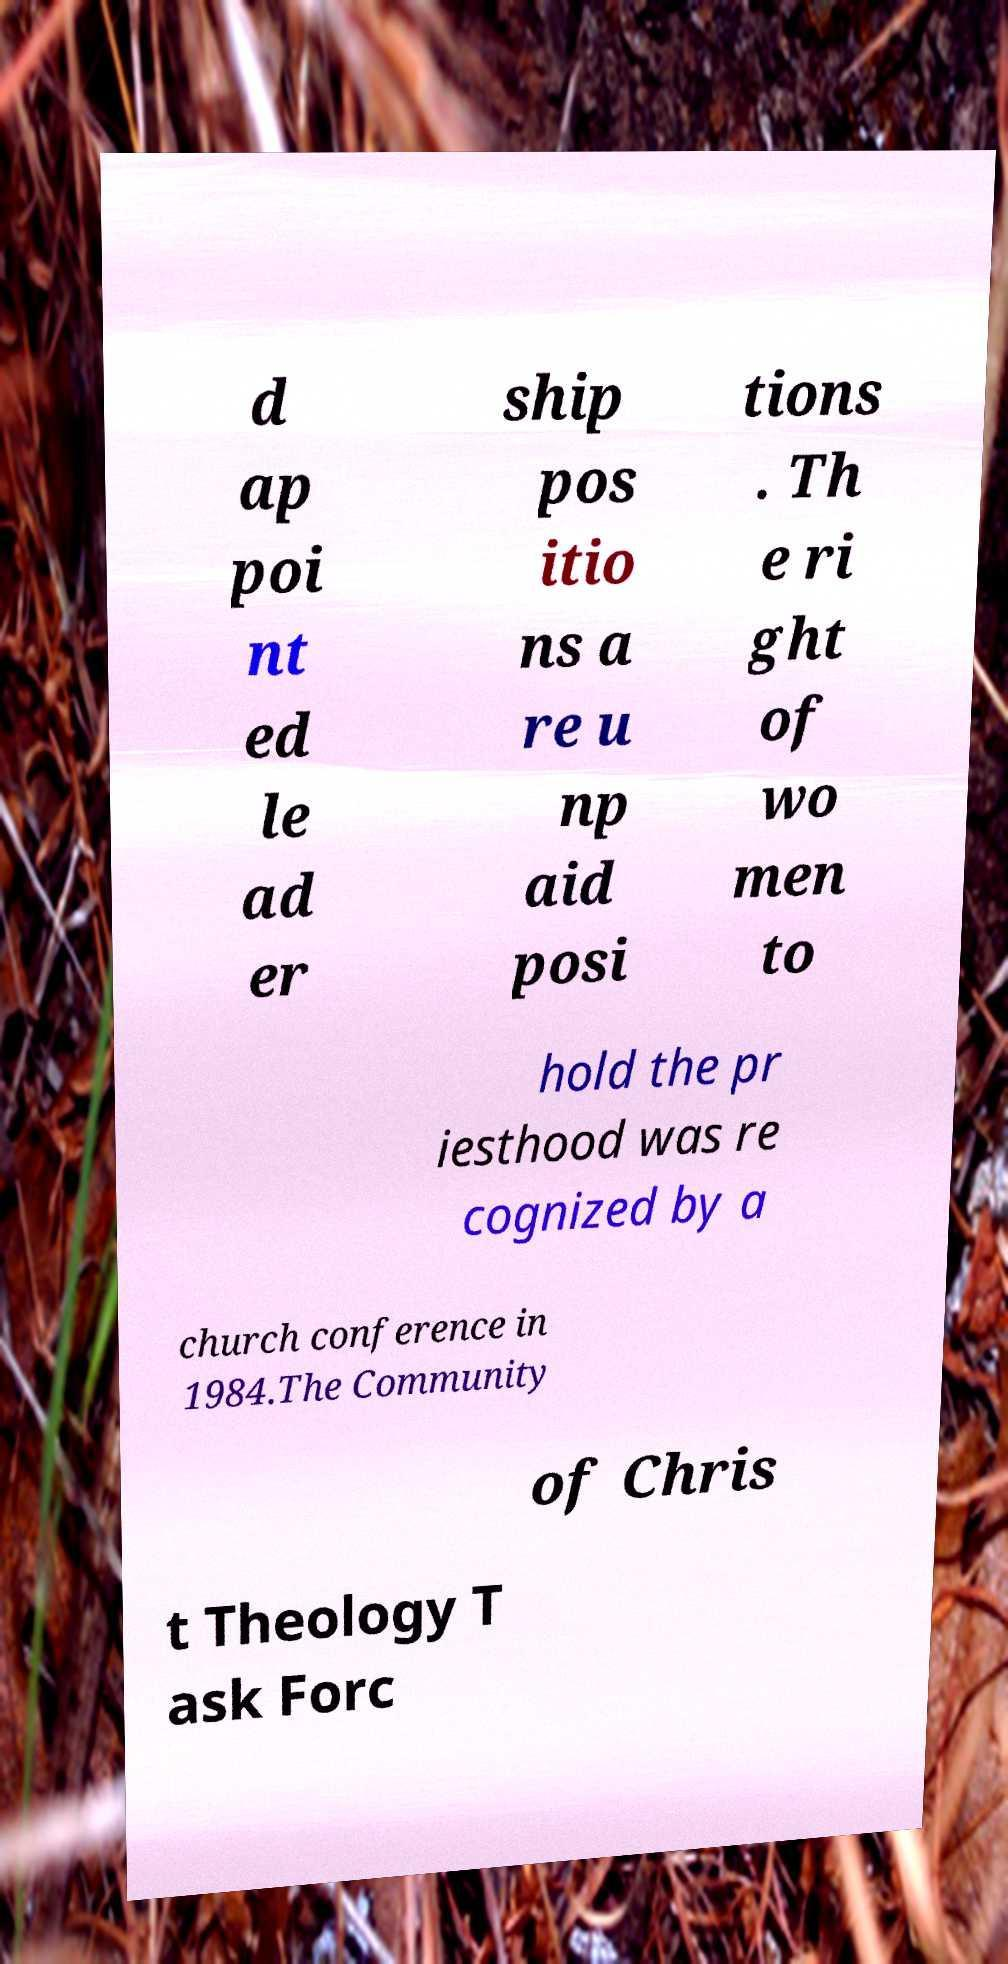What messages or text are displayed in this image? I need them in a readable, typed format. d ap poi nt ed le ad er ship pos itio ns a re u np aid posi tions . Th e ri ght of wo men to hold the pr iesthood was re cognized by a church conference in 1984.The Community of Chris t Theology T ask Forc 